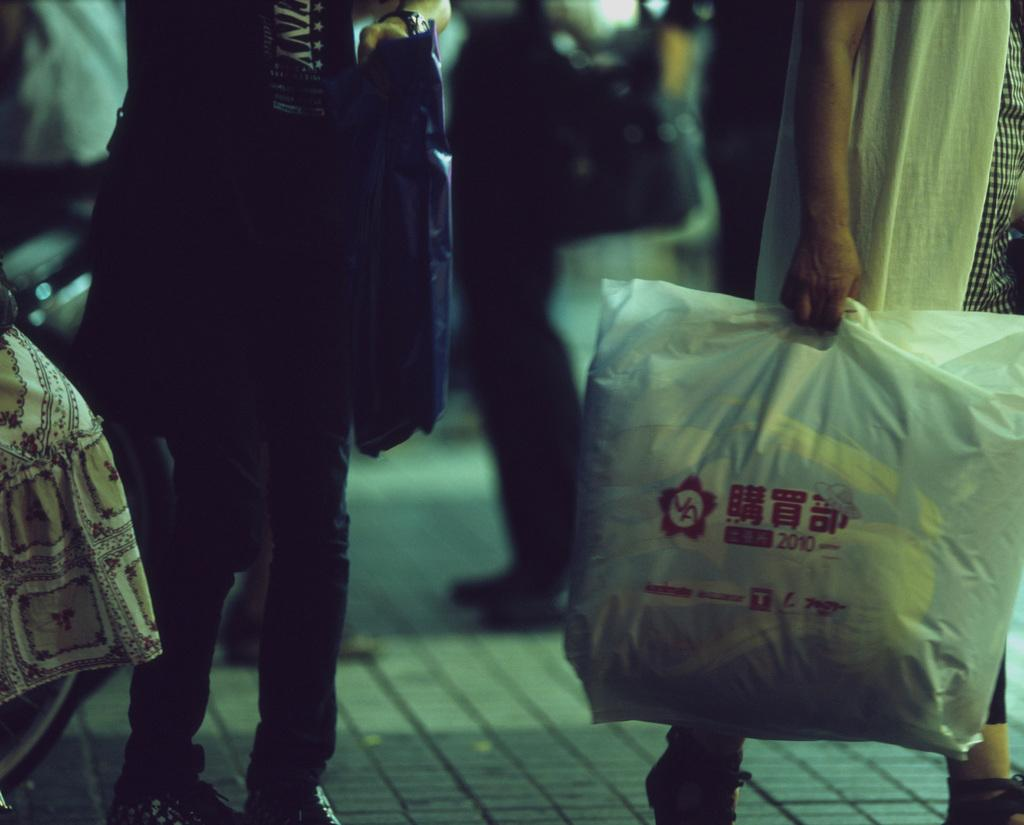How many individuals are present in the image? There are many people in the image. What are the people holding in the image? The people are holding covers. What are the people doing in the image? The people are walking. What type of slip can be seen on the ground in the image? There is no slip present on the ground in the image. 